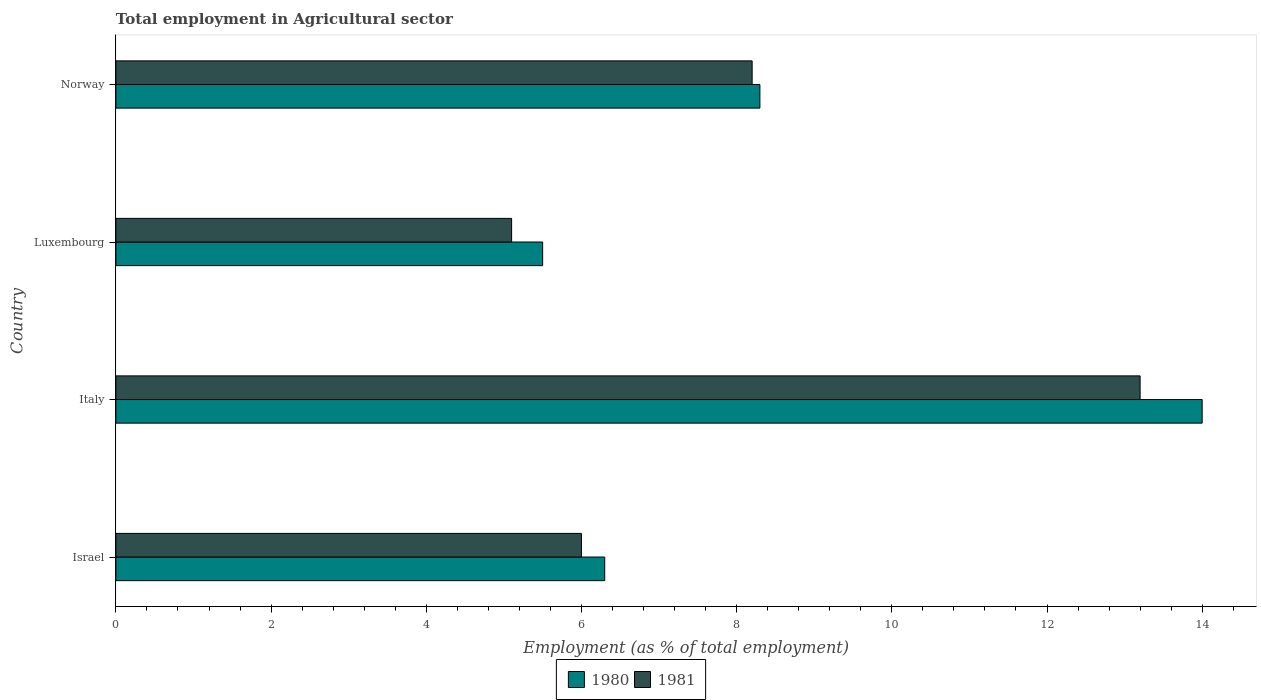Are the number of bars per tick equal to the number of legend labels?
Your response must be concise. Yes. How many bars are there on the 4th tick from the bottom?
Provide a short and direct response. 2. In how many cases, is the number of bars for a given country not equal to the number of legend labels?
Keep it short and to the point. 0. What is the employment in agricultural sector in 1981 in Luxembourg?
Your response must be concise. 5.1. Across all countries, what is the maximum employment in agricultural sector in 1981?
Offer a terse response. 13.2. Across all countries, what is the minimum employment in agricultural sector in 1981?
Your answer should be very brief. 5.1. In which country was the employment in agricultural sector in 1981 maximum?
Ensure brevity in your answer.  Italy. In which country was the employment in agricultural sector in 1981 minimum?
Your response must be concise. Luxembourg. What is the total employment in agricultural sector in 1980 in the graph?
Offer a very short reply. 34.1. What is the difference between the employment in agricultural sector in 1980 in Israel and that in Norway?
Your answer should be very brief. -2. What is the difference between the employment in agricultural sector in 1980 in Luxembourg and the employment in agricultural sector in 1981 in Norway?
Provide a succinct answer. -2.7. What is the average employment in agricultural sector in 1981 per country?
Offer a very short reply. 8.12. What is the difference between the employment in agricultural sector in 1980 and employment in agricultural sector in 1981 in Luxembourg?
Offer a very short reply. 0.4. What is the ratio of the employment in agricultural sector in 1980 in Israel to that in Norway?
Ensure brevity in your answer.  0.76. What is the difference between the highest and the second highest employment in agricultural sector in 1980?
Make the answer very short. 5.7. What is the difference between the highest and the lowest employment in agricultural sector in 1980?
Your answer should be compact. 8.5. What does the 1st bar from the top in Italy represents?
Provide a short and direct response. 1981. What does the 1st bar from the bottom in Israel represents?
Keep it short and to the point. 1980. Does the graph contain any zero values?
Provide a short and direct response. No. Does the graph contain grids?
Provide a short and direct response. No. Where does the legend appear in the graph?
Offer a terse response. Bottom center. What is the title of the graph?
Ensure brevity in your answer.  Total employment in Agricultural sector. Does "1987" appear as one of the legend labels in the graph?
Provide a short and direct response. No. What is the label or title of the X-axis?
Your answer should be compact. Employment (as % of total employment). What is the Employment (as % of total employment) of 1980 in Israel?
Your answer should be compact. 6.3. What is the Employment (as % of total employment) in 1981 in Italy?
Your answer should be very brief. 13.2. What is the Employment (as % of total employment) of 1980 in Luxembourg?
Ensure brevity in your answer.  5.5. What is the Employment (as % of total employment) in 1981 in Luxembourg?
Your answer should be compact. 5.1. What is the Employment (as % of total employment) in 1980 in Norway?
Your answer should be very brief. 8.3. What is the Employment (as % of total employment) of 1981 in Norway?
Your answer should be compact. 8.2. Across all countries, what is the maximum Employment (as % of total employment) in 1981?
Give a very brief answer. 13.2. Across all countries, what is the minimum Employment (as % of total employment) in 1980?
Your answer should be compact. 5.5. Across all countries, what is the minimum Employment (as % of total employment) in 1981?
Give a very brief answer. 5.1. What is the total Employment (as % of total employment) in 1980 in the graph?
Provide a short and direct response. 34.1. What is the total Employment (as % of total employment) of 1981 in the graph?
Offer a very short reply. 32.5. What is the difference between the Employment (as % of total employment) in 1981 in Israel and that in Italy?
Provide a short and direct response. -7.2. What is the difference between the Employment (as % of total employment) in 1981 in Israel and that in Luxembourg?
Make the answer very short. 0.9. What is the difference between the Employment (as % of total employment) in 1980 in Israel and that in Norway?
Provide a succinct answer. -2. What is the difference between the Employment (as % of total employment) in 1981 in Israel and that in Norway?
Provide a succinct answer. -2.2. What is the difference between the Employment (as % of total employment) in 1980 in Italy and that in Luxembourg?
Your response must be concise. 8.5. What is the difference between the Employment (as % of total employment) in 1981 in Italy and that in Luxembourg?
Your answer should be compact. 8.1. What is the difference between the Employment (as % of total employment) in 1981 in Luxembourg and that in Norway?
Offer a terse response. -3.1. What is the difference between the Employment (as % of total employment) in 1980 in Israel and the Employment (as % of total employment) in 1981 in Italy?
Provide a short and direct response. -6.9. What is the difference between the Employment (as % of total employment) of 1980 in Israel and the Employment (as % of total employment) of 1981 in Norway?
Make the answer very short. -1.9. What is the average Employment (as % of total employment) in 1980 per country?
Your answer should be compact. 8.53. What is the average Employment (as % of total employment) of 1981 per country?
Make the answer very short. 8.12. What is the difference between the Employment (as % of total employment) of 1980 and Employment (as % of total employment) of 1981 in Luxembourg?
Keep it short and to the point. 0.4. What is the ratio of the Employment (as % of total employment) in 1980 in Israel to that in Italy?
Provide a short and direct response. 0.45. What is the ratio of the Employment (as % of total employment) in 1981 in Israel to that in Italy?
Provide a short and direct response. 0.45. What is the ratio of the Employment (as % of total employment) of 1980 in Israel to that in Luxembourg?
Ensure brevity in your answer.  1.15. What is the ratio of the Employment (as % of total employment) in 1981 in Israel to that in Luxembourg?
Your answer should be very brief. 1.18. What is the ratio of the Employment (as % of total employment) of 1980 in Israel to that in Norway?
Offer a terse response. 0.76. What is the ratio of the Employment (as % of total employment) in 1981 in Israel to that in Norway?
Keep it short and to the point. 0.73. What is the ratio of the Employment (as % of total employment) in 1980 in Italy to that in Luxembourg?
Provide a short and direct response. 2.55. What is the ratio of the Employment (as % of total employment) in 1981 in Italy to that in Luxembourg?
Your answer should be compact. 2.59. What is the ratio of the Employment (as % of total employment) of 1980 in Italy to that in Norway?
Your answer should be compact. 1.69. What is the ratio of the Employment (as % of total employment) of 1981 in Italy to that in Norway?
Provide a short and direct response. 1.61. What is the ratio of the Employment (as % of total employment) in 1980 in Luxembourg to that in Norway?
Your response must be concise. 0.66. What is the ratio of the Employment (as % of total employment) in 1981 in Luxembourg to that in Norway?
Offer a terse response. 0.62. What is the difference between the highest and the lowest Employment (as % of total employment) in 1980?
Provide a succinct answer. 8.5. What is the difference between the highest and the lowest Employment (as % of total employment) of 1981?
Provide a succinct answer. 8.1. 